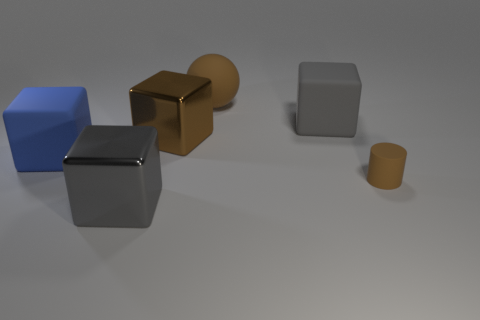What color is the matte sphere that is the same size as the blue rubber cube?
Your response must be concise. Brown. What size is the cube that is the same color as the matte cylinder?
Your answer should be compact. Large. What number of large metallic things have the same color as the tiny rubber cylinder?
Provide a short and direct response. 1. The blue cube that is made of the same material as the ball is what size?
Provide a short and direct response. Large. What number of things are big brown rubber blocks or gray blocks?
Your answer should be compact. 2. The big metallic thing that is left of the big brown cube is what color?
Ensure brevity in your answer.  Gray. What is the size of the blue rubber object that is the same shape as the large gray rubber object?
Offer a very short reply. Large. What number of objects are big objects left of the gray matte cube or brown matte things that are behind the brown cube?
Ensure brevity in your answer.  4. There is a matte object that is both on the right side of the large brown rubber ball and behind the brown matte cylinder; what is its size?
Provide a succinct answer. Large. Do the small matte object and the gray thing that is left of the big ball have the same shape?
Give a very brief answer. No. 